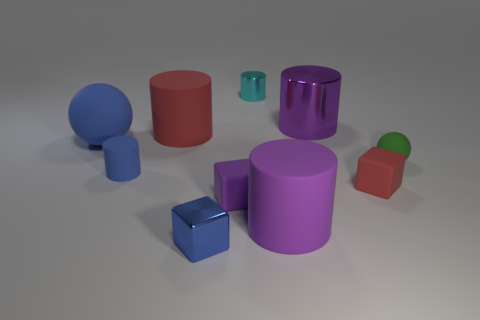There is a red rubber object on the left side of the blue shiny block; are there any metallic things in front of it? While the image does include a variety of objects with different colors and materials, the specific arrangement does not show any items that exhibit metallic characteristics in front of the red rubber object. The materials depicted in the composition primarily consist of matte and glossy surfaces, without the distinct reflective properties associated with metal. 